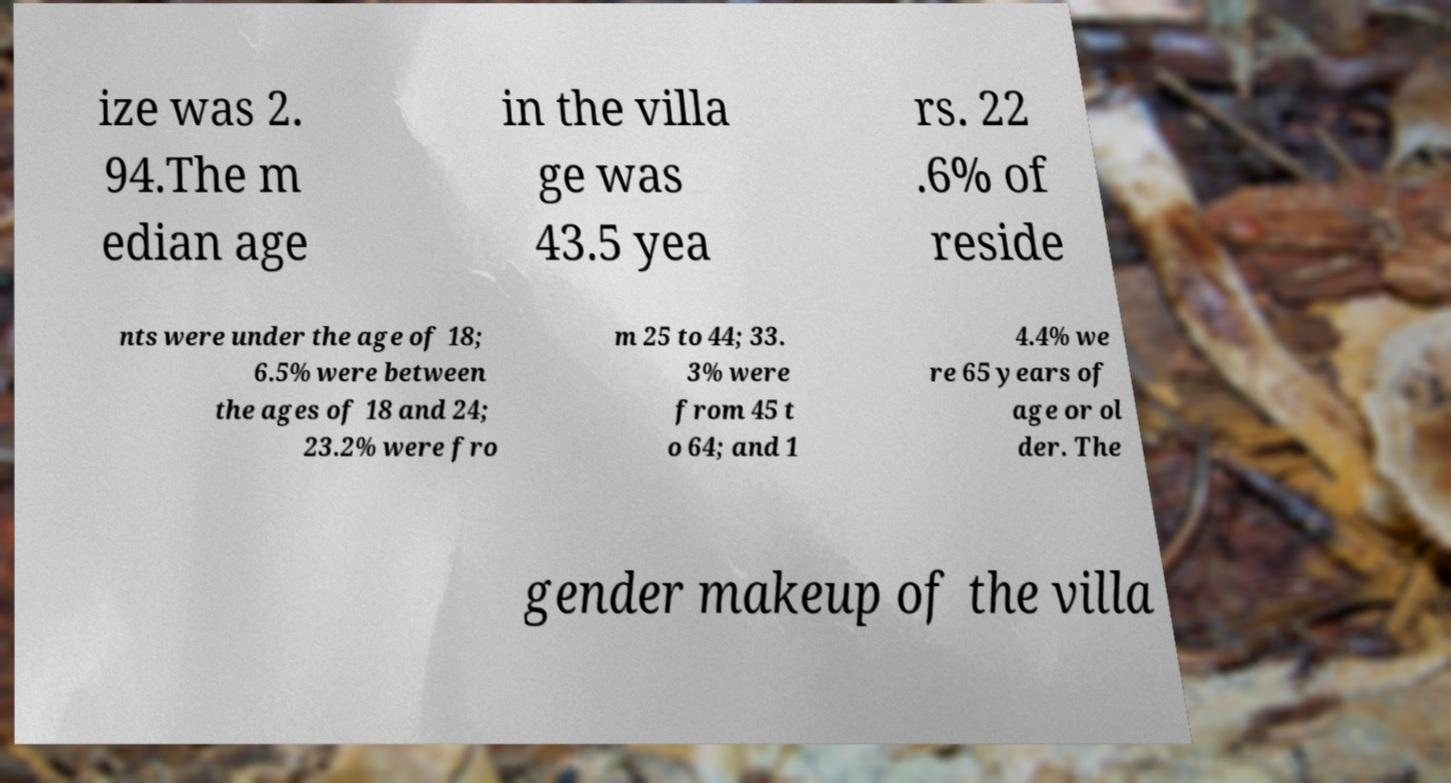Please identify and transcribe the text found in this image. ize was 2. 94.The m edian age in the villa ge was 43.5 yea rs. 22 .6% of reside nts were under the age of 18; 6.5% were between the ages of 18 and 24; 23.2% were fro m 25 to 44; 33. 3% were from 45 t o 64; and 1 4.4% we re 65 years of age or ol der. The gender makeup of the villa 